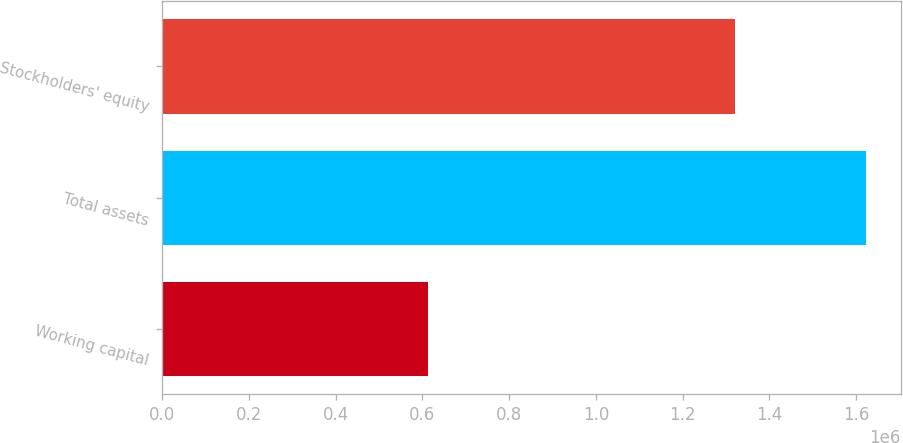Convert chart to OTSL. <chart><loc_0><loc_0><loc_500><loc_500><bar_chart><fcel>Working capital<fcel>Total assets<fcel>Stockholders' equity<nl><fcel>613894<fcel>1.62214e+06<fcel>1.32052e+06<nl></chart> 